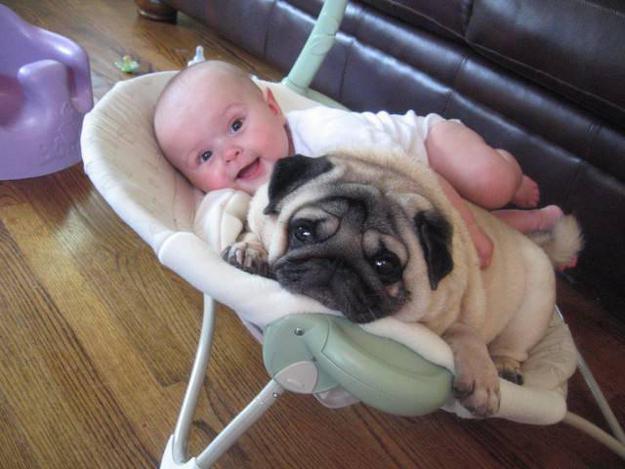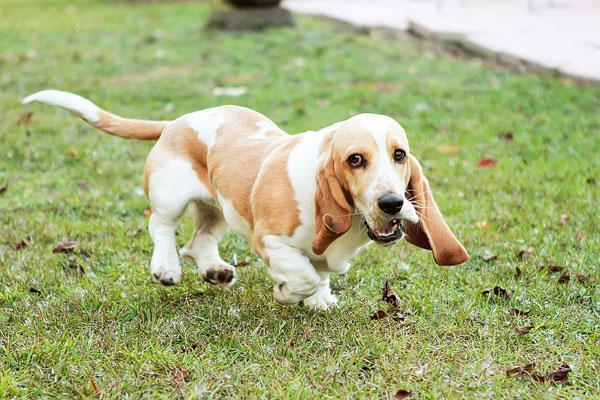The first image is the image on the left, the second image is the image on the right. Considering the images on both sides, is "There is at least one pug and one baby." valid? Answer yes or no. Yes. The first image is the image on the left, the second image is the image on the right. Considering the images on both sides, is "In the right image, there's a single basset hound running through the grass." valid? Answer yes or no. Yes. 